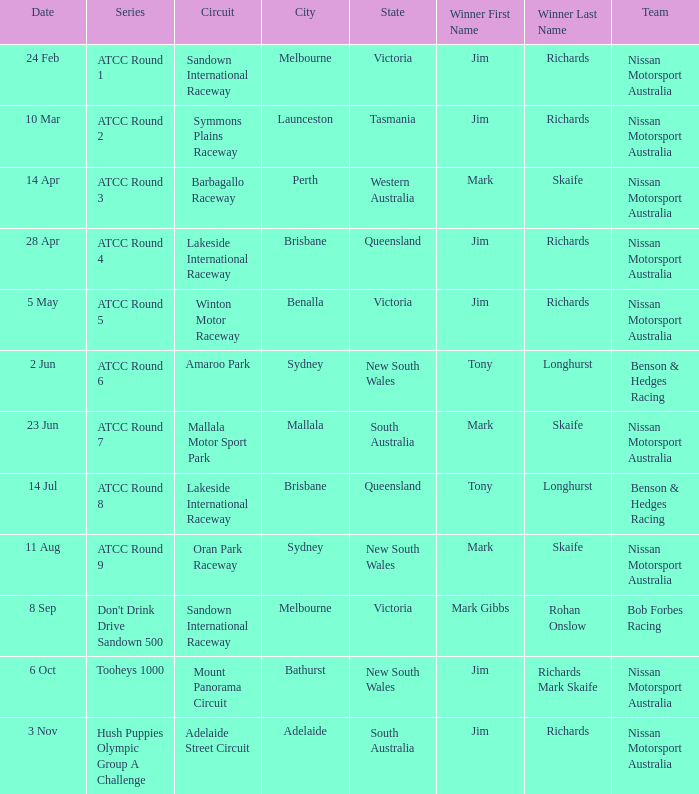Who is the Winner of the Nissan Motorsport Australia Team at the Oran Park Raceway? Mark Skaife. 